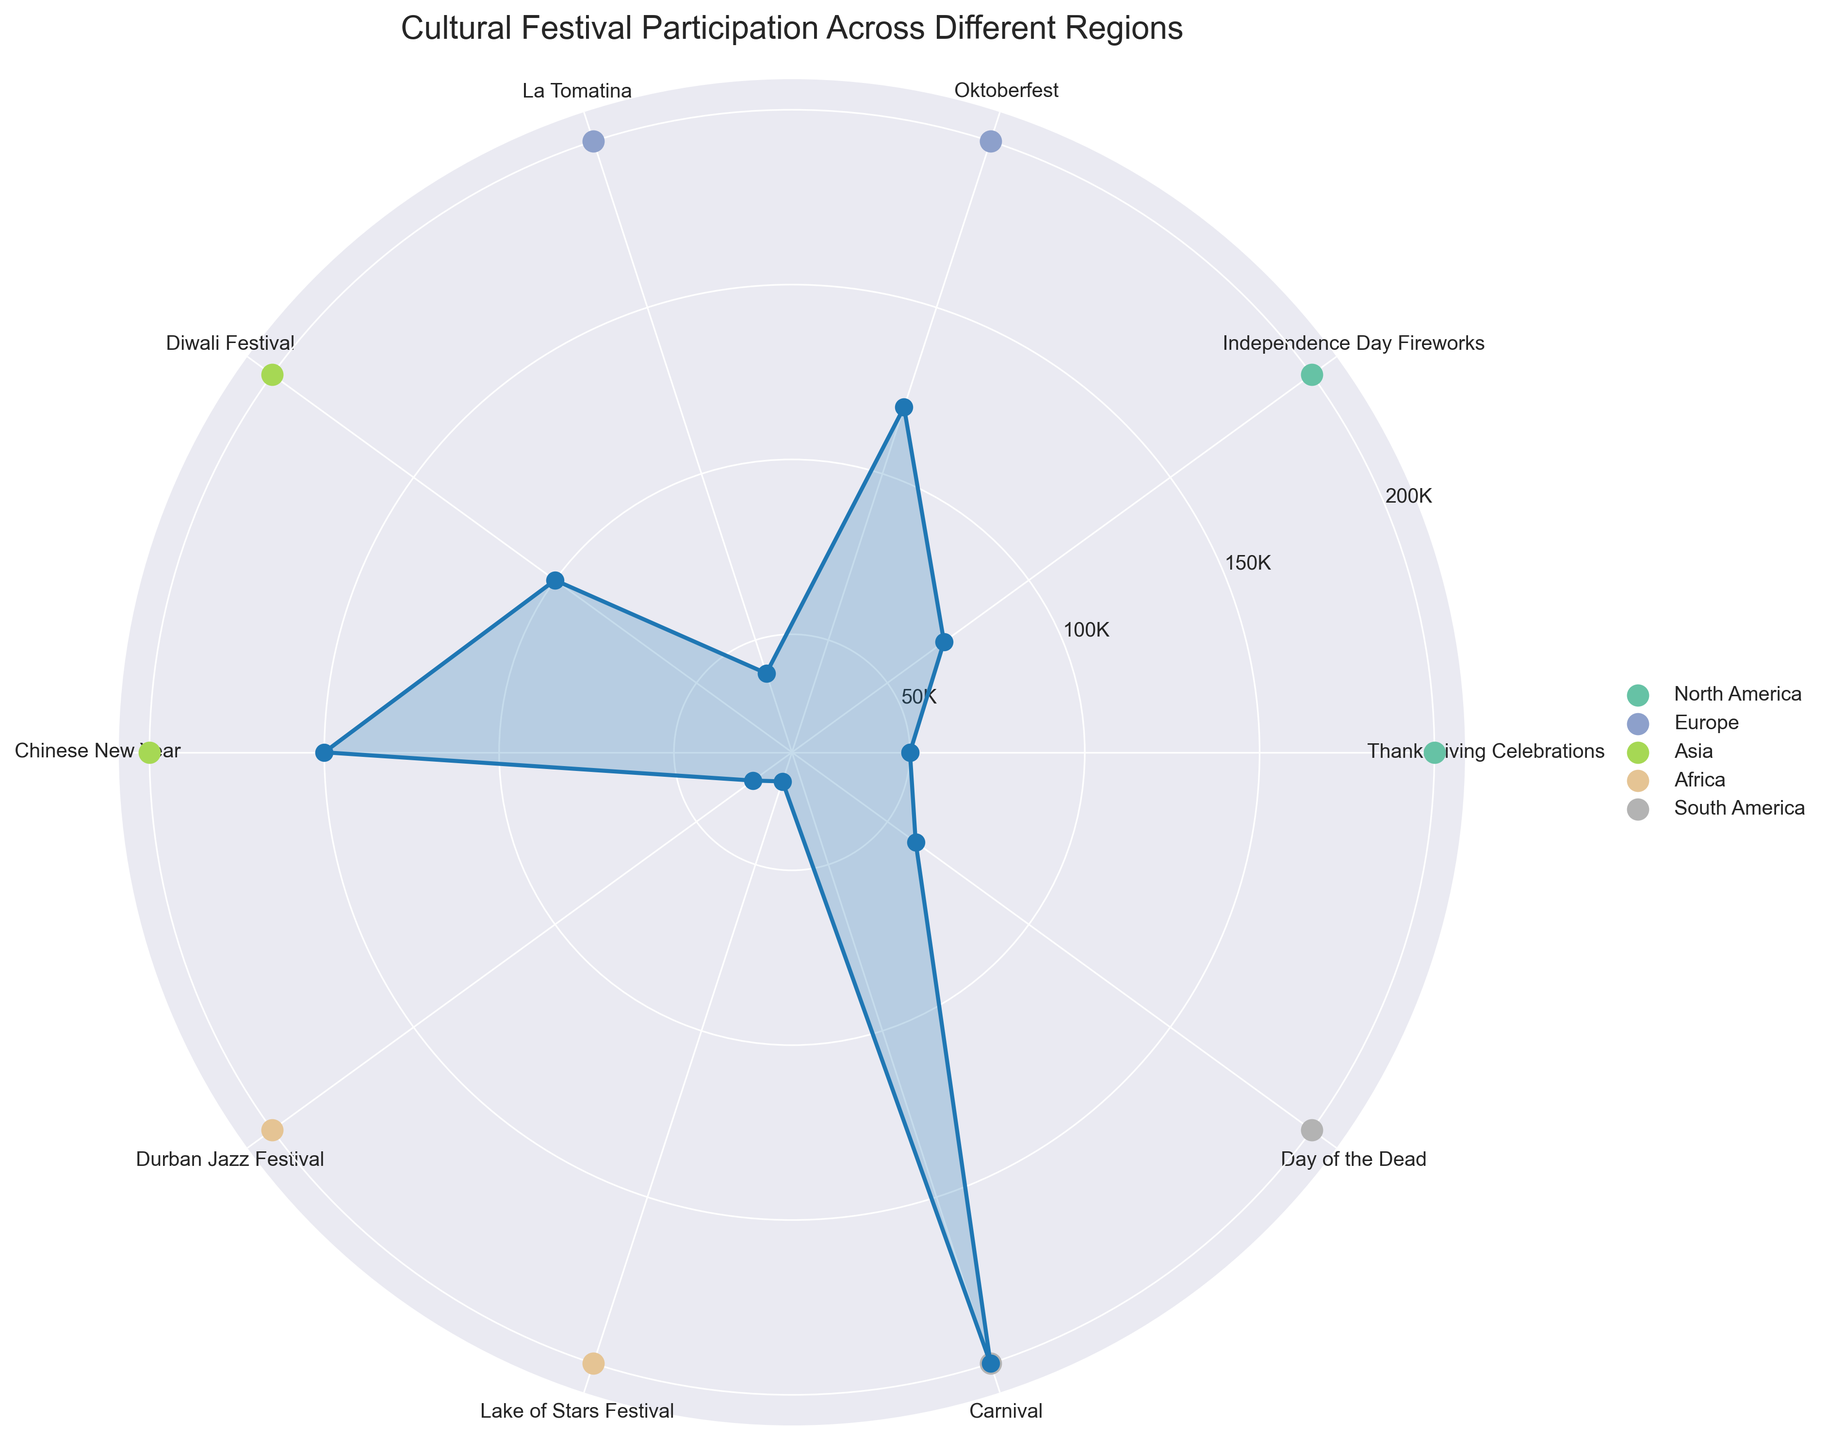What is the festival with the highest participation? The festival with the highest participation can be identified by the longest radius in the chart. Looking at the radial distances, Carnival (200,000) has the longest radius.
Answer: Carnival Which region has the lowest participation in any festival, and what is the festival? Examining the radial distances and the color-coded regions, the festival with the lowest participation is from the Africa region. Lake of Stars Festival has the smallest value (25,000).
Answer: Africa, Lake of Stars Festival How many festivals have more than 100,000 participants? Count the number of radial distances that exceed the 100,000 tick mark. Diwali Festival (100,000), Chinese New Year (150,000), Oktoberfest (120,000), and Carnival (200,000) all exceed 100,000 participants.
Answer: 4 Is the participant count of Chinese New Year greater than La Tomatina and Lake of Stars Festival combined? Chinese New Year has 150,000 participants. Adding La Tomatina (40,000) and Lake of Stars Festival (25,000), the combined total is 65,000. 150,000 is greater than 65,000.
Answer: Yes Which region has the most visible clusters of festivals with high participation rates? By examining the regions indicated by colors and the radial distances, South America (Carnival and Day of the Dead) and Asia (Diwali and Chinese New Year) have the most visible clusters of high participation rates.
Answer: South America and Asia What share of the total participants does North America have, considering both of its festivals? Calculate the total participants for North America: Thanksgiving Celebrations (50,000) and Independence Day Fireworks (70,000). Combined, that is 120,000 participants. Sum up all participant counts from the chart: 50,000 + 70,000 + 120,000 + 40,000 + 100,000 + 150,000 + 30,000 + 25,000 + 200,000 + 60,000 = 845,000. The share is then 120,000 / 845,000 ≈ 0.142 or 14.2%.
Answer: 14.2% Between Diwali Festival and Independence Day Fireworks, which has a higher participant count, and by how much? Diwali Festival has 100,000 participants, while Independence Day Fireworks has 70,000. The difference is 100,000 - 70,000 = 30,000.
Answer: Diwali Festival, by 30,000 What are the radial tick labels provided in the chart? The radial tick labels are the values marked along the radial axis for reference. They are 50K, 100K, 150K, and 200K.
Answer: 50K, 100K, 150K, 200K Which region's festivals are represented by the color with the lightest shade? The color associated with different regions are typically assigned distinct shades. The lightest shade based on the plot color coding is specific to Africa (Durban Jazz Festival and Lake of Stars Festival).
Answer: Africa 